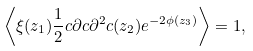Convert formula to latex. <formula><loc_0><loc_0><loc_500><loc_500>\left \langle \xi ( z _ { 1 } ) \frac { 1 } { 2 } c \partial c \partial ^ { 2 } c ( z _ { 2 } ) e ^ { - 2 \phi ( z _ { 3 } ) } \right \rangle = 1 ,</formula> 